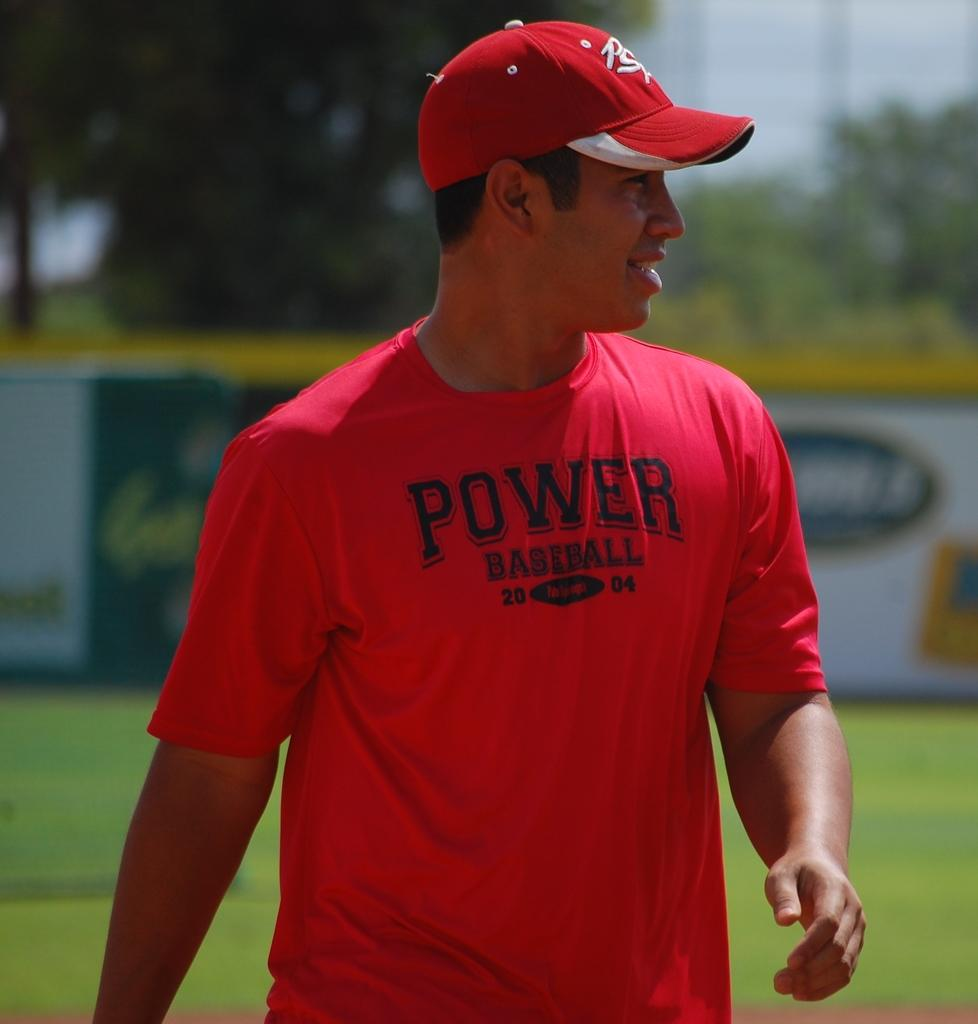<image>
Give a short and clear explanation of the subsequent image. A man wearing red shirt that says "Power Baseball" looks to his left with a grin. 